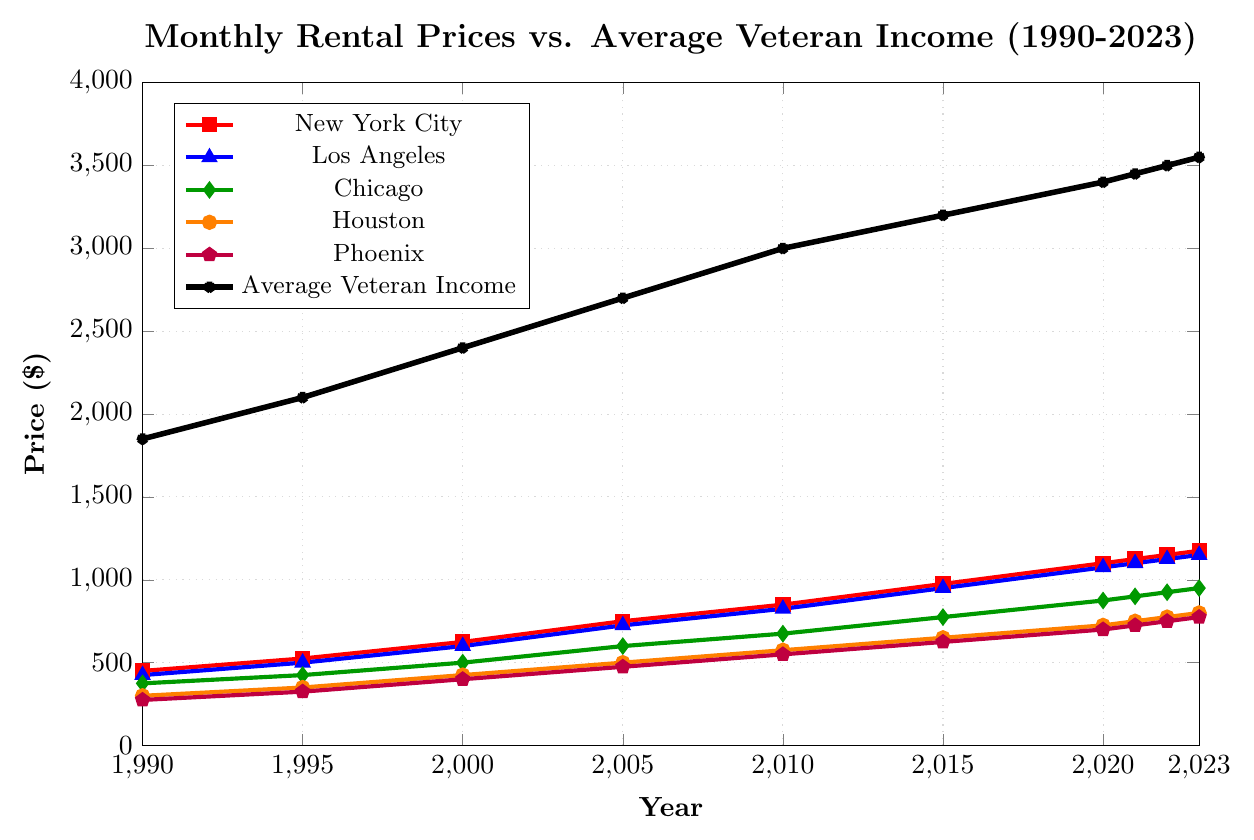What is the trend of rental prices in New York City from 1990 to 2023? The rental prices in New York City have shown a steady increase over the period from 1990 to 2023. Starting from $450 in 1990 and reaching $1175 in 2023, the prices have increased continuously without any decreases.
Answer: Steady increase Which city had the highest rental price in 2023? In 2023, New York City had the highest rental price, which is $1175, compared to other cities
Answer: New York City How does the increase in rental prices in Houston compare from 1990 to 2023? Houston’s rental prices increased from $300 in 1990 to $800 in 2023. To compare, calculate the price increase, which is $800 - $300 = $500.
Answer: $500 By how much has the average veteran income increased from 1990 to 2023? The average veteran income increased from $1850 in 1990 to $3550 in 2023. Calculate the increase: $3550 - $1850 = $1700.
Answer: $1700 Which city showed the most significant increase in rental prices between 1990 and 2023? To find the most significant increase, calculate the difference for each city: New York City: 1175 - 450 = 725, Los Angeles: 1150 - 425 = 725, Chicago: 950 - 375 = 575, Houston: 800 - 300 = 500, Phoenix: 775 - 275 = 500. Both New York City and Los Angeles showed the most significant increase of $725.
Answer: New York City and Los Angeles Is there any year where the rental price in Phoenix was higher than in other cities? Checking each year, Phoenix's rental price is never higher than those in New York City, Los Angeles, Chicago, and Houston for any given year.
Answer: No What is the ratio of the average veteran income to the rental prices in Chicago for the year 2023? For 2023, the average veteran income is $3550, and the rental price in Chicago is $950. Calculate the ratio: 3550 / 950 ≈ 3.74.
Answer: 3.74 What visual attributes distinguish the trend line for Average Veteran Income from the others? The Average Veteran Income line is black in color, marked with stars, and has a line width that is thicker compared to other lines.
Answer: Black with stars, thicker linewidth Which city's rental prices had the closest value to the national average veteran income in 2020? In 2020, the average veteran income was $3400, while the rental prices were New York City: $1100, Los Angeles: $1075, Chicago: $875, Houston: $725, Phoenix: $700. None of the cities had rental prices close to $3400, but New York City had the highest, which is closest relative to the other cities.
Answer: New York City Between 2015 and 2023, which city had the smallest increase in rental prices? Calculate the difference for each city: New York City: 1175 - 975 = 200, Los Angeles: 1150 - 950 = 200, Chicago: 950 - 775 = 175, Houston: 800 - 650 = 150, Phoenix: 775 - 625 = 150. Houston and Phoenix both had the smallest increase of $150.
Answer: Houston and Phoenix 